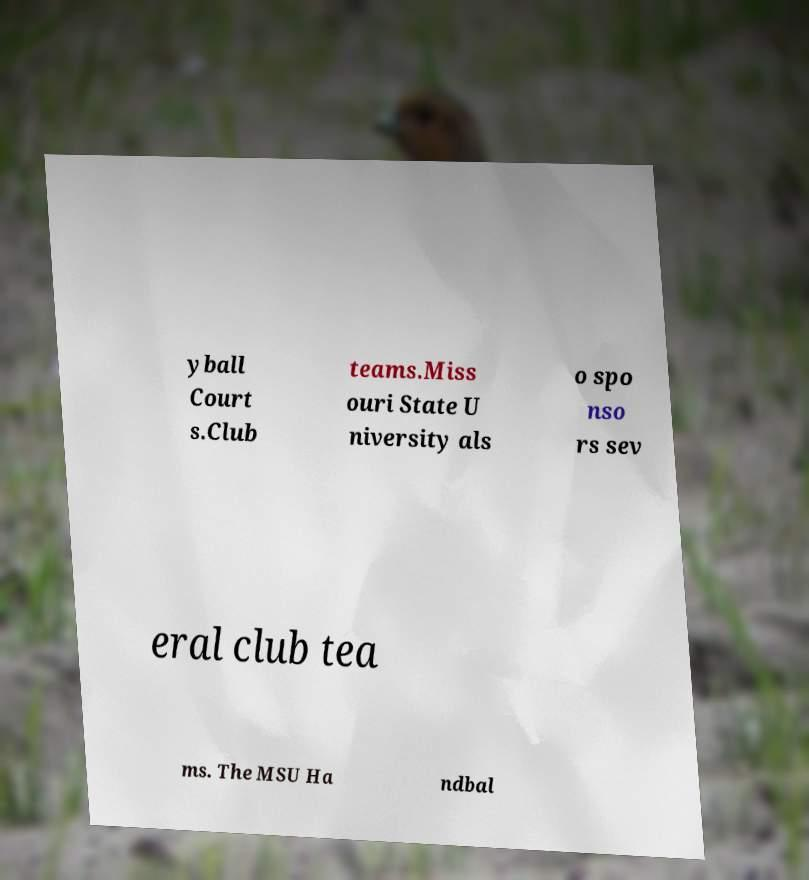What messages or text are displayed in this image? I need them in a readable, typed format. yball Court s.Club teams.Miss ouri State U niversity als o spo nso rs sev eral club tea ms. The MSU Ha ndbal 